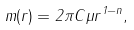Convert formula to latex. <formula><loc_0><loc_0><loc_500><loc_500>m ( r ) = 2 \pi C \mu r ^ { 1 - n } ,</formula> 